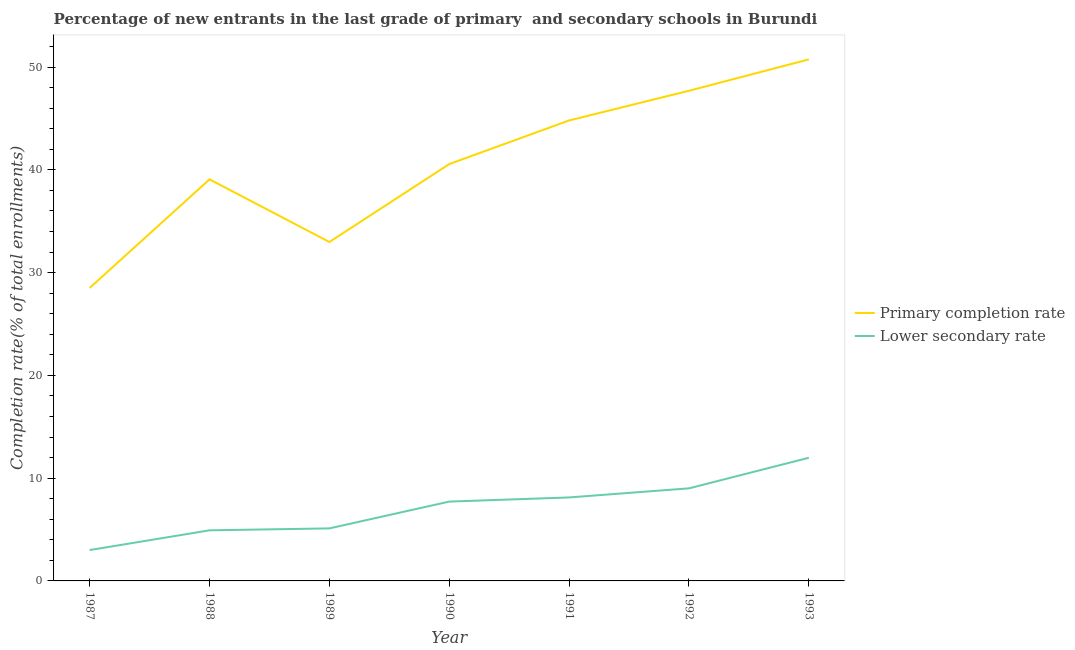What is the completion rate in primary schools in 1991?
Keep it short and to the point. 44.81. Across all years, what is the maximum completion rate in primary schools?
Your answer should be very brief. 50.75. Across all years, what is the minimum completion rate in primary schools?
Your answer should be compact. 28.51. In which year was the completion rate in secondary schools minimum?
Make the answer very short. 1987. What is the total completion rate in primary schools in the graph?
Provide a short and direct response. 284.41. What is the difference between the completion rate in secondary schools in 1987 and that in 1988?
Offer a very short reply. -1.92. What is the difference between the completion rate in secondary schools in 1993 and the completion rate in primary schools in 1992?
Make the answer very short. -35.72. What is the average completion rate in primary schools per year?
Your answer should be very brief. 40.63. In the year 1991, what is the difference between the completion rate in secondary schools and completion rate in primary schools?
Offer a terse response. -36.69. In how many years, is the completion rate in primary schools greater than 10 %?
Your answer should be very brief. 7. What is the ratio of the completion rate in secondary schools in 1988 to that in 1991?
Your response must be concise. 0.61. What is the difference between the highest and the second highest completion rate in primary schools?
Offer a very short reply. 3.05. What is the difference between the highest and the lowest completion rate in primary schools?
Offer a terse response. 22.24. Is the sum of the completion rate in secondary schools in 1991 and 1992 greater than the maximum completion rate in primary schools across all years?
Keep it short and to the point. No. Is the completion rate in secondary schools strictly greater than the completion rate in primary schools over the years?
Offer a terse response. No. Is the completion rate in secondary schools strictly less than the completion rate in primary schools over the years?
Keep it short and to the point. Yes. How many years are there in the graph?
Your answer should be very brief. 7. Where does the legend appear in the graph?
Provide a short and direct response. Center right. How are the legend labels stacked?
Provide a short and direct response. Vertical. What is the title of the graph?
Keep it short and to the point. Percentage of new entrants in the last grade of primary  and secondary schools in Burundi. What is the label or title of the Y-axis?
Provide a succinct answer. Completion rate(% of total enrollments). What is the Completion rate(% of total enrollments) in Primary completion rate in 1987?
Give a very brief answer. 28.51. What is the Completion rate(% of total enrollments) in Lower secondary rate in 1987?
Ensure brevity in your answer.  3. What is the Completion rate(% of total enrollments) of Primary completion rate in 1988?
Make the answer very short. 39.08. What is the Completion rate(% of total enrollments) of Lower secondary rate in 1988?
Offer a very short reply. 4.92. What is the Completion rate(% of total enrollments) of Primary completion rate in 1989?
Your response must be concise. 32.98. What is the Completion rate(% of total enrollments) in Lower secondary rate in 1989?
Keep it short and to the point. 5.11. What is the Completion rate(% of total enrollments) in Primary completion rate in 1990?
Your answer should be compact. 40.57. What is the Completion rate(% of total enrollments) in Lower secondary rate in 1990?
Offer a terse response. 7.72. What is the Completion rate(% of total enrollments) of Primary completion rate in 1991?
Your response must be concise. 44.81. What is the Completion rate(% of total enrollments) of Lower secondary rate in 1991?
Make the answer very short. 8.12. What is the Completion rate(% of total enrollments) of Primary completion rate in 1992?
Offer a very short reply. 47.7. What is the Completion rate(% of total enrollments) of Lower secondary rate in 1992?
Your answer should be compact. 9.01. What is the Completion rate(% of total enrollments) in Primary completion rate in 1993?
Offer a terse response. 50.75. What is the Completion rate(% of total enrollments) in Lower secondary rate in 1993?
Your answer should be very brief. 11.98. Across all years, what is the maximum Completion rate(% of total enrollments) in Primary completion rate?
Offer a terse response. 50.75. Across all years, what is the maximum Completion rate(% of total enrollments) of Lower secondary rate?
Offer a terse response. 11.98. Across all years, what is the minimum Completion rate(% of total enrollments) in Primary completion rate?
Your answer should be compact. 28.51. Across all years, what is the minimum Completion rate(% of total enrollments) of Lower secondary rate?
Provide a short and direct response. 3. What is the total Completion rate(% of total enrollments) of Primary completion rate in the graph?
Make the answer very short. 284.41. What is the total Completion rate(% of total enrollments) in Lower secondary rate in the graph?
Your answer should be compact. 49.88. What is the difference between the Completion rate(% of total enrollments) in Primary completion rate in 1987 and that in 1988?
Keep it short and to the point. -10.57. What is the difference between the Completion rate(% of total enrollments) of Lower secondary rate in 1987 and that in 1988?
Provide a short and direct response. -1.92. What is the difference between the Completion rate(% of total enrollments) in Primary completion rate in 1987 and that in 1989?
Your answer should be very brief. -4.47. What is the difference between the Completion rate(% of total enrollments) of Lower secondary rate in 1987 and that in 1989?
Offer a very short reply. -2.11. What is the difference between the Completion rate(% of total enrollments) in Primary completion rate in 1987 and that in 1990?
Offer a terse response. -12.05. What is the difference between the Completion rate(% of total enrollments) of Lower secondary rate in 1987 and that in 1990?
Make the answer very short. -4.72. What is the difference between the Completion rate(% of total enrollments) of Primary completion rate in 1987 and that in 1991?
Provide a succinct answer. -16.3. What is the difference between the Completion rate(% of total enrollments) in Lower secondary rate in 1987 and that in 1991?
Give a very brief answer. -5.12. What is the difference between the Completion rate(% of total enrollments) of Primary completion rate in 1987 and that in 1992?
Your answer should be very brief. -19.19. What is the difference between the Completion rate(% of total enrollments) of Lower secondary rate in 1987 and that in 1992?
Offer a very short reply. -6.01. What is the difference between the Completion rate(% of total enrollments) in Primary completion rate in 1987 and that in 1993?
Provide a succinct answer. -22.24. What is the difference between the Completion rate(% of total enrollments) of Lower secondary rate in 1987 and that in 1993?
Your answer should be very brief. -8.98. What is the difference between the Completion rate(% of total enrollments) of Primary completion rate in 1988 and that in 1989?
Offer a terse response. 6.09. What is the difference between the Completion rate(% of total enrollments) in Lower secondary rate in 1988 and that in 1989?
Give a very brief answer. -0.19. What is the difference between the Completion rate(% of total enrollments) in Primary completion rate in 1988 and that in 1990?
Provide a short and direct response. -1.49. What is the difference between the Completion rate(% of total enrollments) of Lower secondary rate in 1988 and that in 1990?
Your answer should be very brief. -2.8. What is the difference between the Completion rate(% of total enrollments) in Primary completion rate in 1988 and that in 1991?
Your answer should be very brief. -5.73. What is the difference between the Completion rate(% of total enrollments) of Lower secondary rate in 1988 and that in 1991?
Offer a very short reply. -3.2. What is the difference between the Completion rate(% of total enrollments) of Primary completion rate in 1988 and that in 1992?
Your answer should be very brief. -8.62. What is the difference between the Completion rate(% of total enrollments) of Lower secondary rate in 1988 and that in 1992?
Your answer should be compact. -4.09. What is the difference between the Completion rate(% of total enrollments) in Primary completion rate in 1988 and that in 1993?
Provide a short and direct response. -11.67. What is the difference between the Completion rate(% of total enrollments) in Lower secondary rate in 1988 and that in 1993?
Provide a succinct answer. -7.06. What is the difference between the Completion rate(% of total enrollments) of Primary completion rate in 1989 and that in 1990?
Your response must be concise. -7.58. What is the difference between the Completion rate(% of total enrollments) in Lower secondary rate in 1989 and that in 1990?
Make the answer very short. -2.61. What is the difference between the Completion rate(% of total enrollments) in Primary completion rate in 1989 and that in 1991?
Provide a short and direct response. -11.83. What is the difference between the Completion rate(% of total enrollments) in Lower secondary rate in 1989 and that in 1991?
Ensure brevity in your answer.  -3.01. What is the difference between the Completion rate(% of total enrollments) in Primary completion rate in 1989 and that in 1992?
Your answer should be compact. -14.72. What is the difference between the Completion rate(% of total enrollments) of Lower secondary rate in 1989 and that in 1992?
Offer a terse response. -3.9. What is the difference between the Completion rate(% of total enrollments) in Primary completion rate in 1989 and that in 1993?
Offer a terse response. -17.77. What is the difference between the Completion rate(% of total enrollments) of Lower secondary rate in 1989 and that in 1993?
Ensure brevity in your answer.  -6.87. What is the difference between the Completion rate(% of total enrollments) of Primary completion rate in 1990 and that in 1991?
Offer a very short reply. -4.24. What is the difference between the Completion rate(% of total enrollments) in Lower secondary rate in 1990 and that in 1991?
Offer a very short reply. -0.4. What is the difference between the Completion rate(% of total enrollments) in Primary completion rate in 1990 and that in 1992?
Provide a succinct answer. -7.13. What is the difference between the Completion rate(% of total enrollments) in Lower secondary rate in 1990 and that in 1992?
Keep it short and to the point. -1.29. What is the difference between the Completion rate(% of total enrollments) in Primary completion rate in 1990 and that in 1993?
Give a very brief answer. -10.19. What is the difference between the Completion rate(% of total enrollments) of Lower secondary rate in 1990 and that in 1993?
Give a very brief answer. -4.26. What is the difference between the Completion rate(% of total enrollments) in Primary completion rate in 1991 and that in 1992?
Provide a short and direct response. -2.89. What is the difference between the Completion rate(% of total enrollments) in Lower secondary rate in 1991 and that in 1992?
Offer a very short reply. -0.89. What is the difference between the Completion rate(% of total enrollments) in Primary completion rate in 1991 and that in 1993?
Your answer should be very brief. -5.94. What is the difference between the Completion rate(% of total enrollments) in Lower secondary rate in 1991 and that in 1993?
Provide a succinct answer. -3.86. What is the difference between the Completion rate(% of total enrollments) of Primary completion rate in 1992 and that in 1993?
Ensure brevity in your answer.  -3.05. What is the difference between the Completion rate(% of total enrollments) in Lower secondary rate in 1992 and that in 1993?
Offer a very short reply. -2.97. What is the difference between the Completion rate(% of total enrollments) of Primary completion rate in 1987 and the Completion rate(% of total enrollments) of Lower secondary rate in 1988?
Provide a short and direct response. 23.59. What is the difference between the Completion rate(% of total enrollments) in Primary completion rate in 1987 and the Completion rate(% of total enrollments) in Lower secondary rate in 1989?
Give a very brief answer. 23.4. What is the difference between the Completion rate(% of total enrollments) of Primary completion rate in 1987 and the Completion rate(% of total enrollments) of Lower secondary rate in 1990?
Your response must be concise. 20.79. What is the difference between the Completion rate(% of total enrollments) of Primary completion rate in 1987 and the Completion rate(% of total enrollments) of Lower secondary rate in 1991?
Make the answer very short. 20.39. What is the difference between the Completion rate(% of total enrollments) of Primary completion rate in 1987 and the Completion rate(% of total enrollments) of Lower secondary rate in 1992?
Keep it short and to the point. 19.5. What is the difference between the Completion rate(% of total enrollments) in Primary completion rate in 1987 and the Completion rate(% of total enrollments) in Lower secondary rate in 1993?
Provide a short and direct response. 16.53. What is the difference between the Completion rate(% of total enrollments) in Primary completion rate in 1988 and the Completion rate(% of total enrollments) in Lower secondary rate in 1989?
Provide a succinct answer. 33.97. What is the difference between the Completion rate(% of total enrollments) of Primary completion rate in 1988 and the Completion rate(% of total enrollments) of Lower secondary rate in 1990?
Your response must be concise. 31.36. What is the difference between the Completion rate(% of total enrollments) of Primary completion rate in 1988 and the Completion rate(% of total enrollments) of Lower secondary rate in 1991?
Make the answer very short. 30.95. What is the difference between the Completion rate(% of total enrollments) of Primary completion rate in 1988 and the Completion rate(% of total enrollments) of Lower secondary rate in 1992?
Provide a succinct answer. 30.07. What is the difference between the Completion rate(% of total enrollments) of Primary completion rate in 1988 and the Completion rate(% of total enrollments) of Lower secondary rate in 1993?
Offer a terse response. 27.09. What is the difference between the Completion rate(% of total enrollments) in Primary completion rate in 1989 and the Completion rate(% of total enrollments) in Lower secondary rate in 1990?
Offer a very short reply. 25.26. What is the difference between the Completion rate(% of total enrollments) of Primary completion rate in 1989 and the Completion rate(% of total enrollments) of Lower secondary rate in 1991?
Provide a succinct answer. 24.86. What is the difference between the Completion rate(% of total enrollments) in Primary completion rate in 1989 and the Completion rate(% of total enrollments) in Lower secondary rate in 1992?
Make the answer very short. 23.97. What is the difference between the Completion rate(% of total enrollments) in Primary completion rate in 1989 and the Completion rate(% of total enrollments) in Lower secondary rate in 1993?
Give a very brief answer. 21. What is the difference between the Completion rate(% of total enrollments) of Primary completion rate in 1990 and the Completion rate(% of total enrollments) of Lower secondary rate in 1991?
Keep it short and to the point. 32.44. What is the difference between the Completion rate(% of total enrollments) in Primary completion rate in 1990 and the Completion rate(% of total enrollments) in Lower secondary rate in 1992?
Your answer should be compact. 31.56. What is the difference between the Completion rate(% of total enrollments) in Primary completion rate in 1990 and the Completion rate(% of total enrollments) in Lower secondary rate in 1993?
Your answer should be compact. 28.58. What is the difference between the Completion rate(% of total enrollments) of Primary completion rate in 1991 and the Completion rate(% of total enrollments) of Lower secondary rate in 1992?
Your answer should be compact. 35.8. What is the difference between the Completion rate(% of total enrollments) in Primary completion rate in 1991 and the Completion rate(% of total enrollments) in Lower secondary rate in 1993?
Give a very brief answer. 32.83. What is the difference between the Completion rate(% of total enrollments) in Primary completion rate in 1992 and the Completion rate(% of total enrollments) in Lower secondary rate in 1993?
Give a very brief answer. 35.72. What is the average Completion rate(% of total enrollments) in Primary completion rate per year?
Provide a succinct answer. 40.63. What is the average Completion rate(% of total enrollments) in Lower secondary rate per year?
Your answer should be compact. 7.13. In the year 1987, what is the difference between the Completion rate(% of total enrollments) in Primary completion rate and Completion rate(% of total enrollments) in Lower secondary rate?
Provide a short and direct response. 25.51. In the year 1988, what is the difference between the Completion rate(% of total enrollments) of Primary completion rate and Completion rate(% of total enrollments) of Lower secondary rate?
Provide a succinct answer. 34.16. In the year 1989, what is the difference between the Completion rate(% of total enrollments) of Primary completion rate and Completion rate(% of total enrollments) of Lower secondary rate?
Make the answer very short. 27.87. In the year 1990, what is the difference between the Completion rate(% of total enrollments) of Primary completion rate and Completion rate(% of total enrollments) of Lower secondary rate?
Your answer should be very brief. 32.85. In the year 1991, what is the difference between the Completion rate(% of total enrollments) in Primary completion rate and Completion rate(% of total enrollments) in Lower secondary rate?
Provide a succinct answer. 36.69. In the year 1992, what is the difference between the Completion rate(% of total enrollments) of Primary completion rate and Completion rate(% of total enrollments) of Lower secondary rate?
Offer a very short reply. 38.69. In the year 1993, what is the difference between the Completion rate(% of total enrollments) in Primary completion rate and Completion rate(% of total enrollments) in Lower secondary rate?
Offer a terse response. 38.77. What is the ratio of the Completion rate(% of total enrollments) in Primary completion rate in 1987 to that in 1988?
Make the answer very short. 0.73. What is the ratio of the Completion rate(% of total enrollments) of Lower secondary rate in 1987 to that in 1988?
Your answer should be very brief. 0.61. What is the ratio of the Completion rate(% of total enrollments) of Primary completion rate in 1987 to that in 1989?
Offer a very short reply. 0.86. What is the ratio of the Completion rate(% of total enrollments) of Lower secondary rate in 1987 to that in 1989?
Offer a very short reply. 0.59. What is the ratio of the Completion rate(% of total enrollments) of Primary completion rate in 1987 to that in 1990?
Provide a short and direct response. 0.7. What is the ratio of the Completion rate(% of total enrollments) of Lower secondary rate in 1987 to that in 1990?
Your response must be concise. 0.39. What is the ratio of the Completion rate(% of total enrollments) in Primary completion rate in 1987 to that in 1991?
Make the answer very short. 0.64. What is the ratio of the Completion rate(% of total enrollments) of Lower secondary rate in 1987 to that in 1991?
Make the answer very short. 0.37. What is the ratio of the Completion rate(% of total enrollments) of Primary completion rate in 1987 to that in 1992?
Keep it short and to the point. 0.6. What is the ratio of the Completion rate(% of total enrollments) of Lower secondary rate in 1987 to that in 1992?
Make the answer very short. 0.33. What is the ratio of the Completion rate(% of total enrollments) of Primary completion rate in 1987 to that in 1993?
Give a very brief answer. 0.56. What is the ratio of the Completion rate(% of total enrollments) of Lower secondary rate in 1987 to that in 1993?
Provide a succinct answer. 0.25. What is the ratio of the Completion rate(% of total enrollments) in Primary completion rate in 1988 to that in 1989?
Give a very brief answer. 1.18. What is the ratio of the Completion rate(% of total enrollments) in Lower secondary rate in 1988 to that in 1989?
Ensure brevity in your answer.  0.96. What is the ratio of the Completion rate(% of total enrollments) in Primary completion rate in 1988 to that in 1990?
Offer a terse response. 0.96. What is the ratio of the Completion rate(% of total enrollments) in Lower secondary rate in 1988 to that in 1990?
Your answer should be compact. 0.64. What is the ratio of the Completion rate(% of total enrollments) in Primary completion rate in 1988 to that in 1991?
Your answer should be very brief. 0.87. What is the ratio of the Completion rate(% of total enrollments) of Lower secondary rate in 1988 to that in 1991?
Ensure brevity in your answer.  0.61. What is the ratio of the Completion rate(% of total enrollments) in Primary completion rate in 1988 to that in 1992?
Your response must be concise. 0.82. What is the ratio of the Completion rate(% of total enrollments) in Lower secondary rate in 1988 to that in 1992?
Your answer should be compact. 0.55. What is the ratio of the Completion rate(% of total enrollments) in Primary completion rate in 1988 to that in 1993?
Provide a short and direct response. 0.77. What is the ratio of the Completion rate(% of total enrollments) of Lower secondary rate in 1988 to that in 1993?
Give a very brief answer. 0.41. What is the ratio of the Completion rate(% of total enrollments) in Primary completion rate in 1989 to that in 1990?
Offer a very short reply. 0.81. What is the ratio of the Completion rate(% of total enrollments) of Lower secondary rate in 1989 to that in 1990?
Keep it short and to the point. 0.66. What is the ratio of the Completion rate(% of total enrollments) in Primary completion rate in 1989 to that in 1991?
Ensure brevity in your answer.  0.74. What is the ratio of the Completion rate(% of total enrollments) of Lower secondary rate in 1989 to that in 1991?
Ensure brevity in your answer.  0.63. What is the ratio of the Completion rate(% of total enrollments) in Primary completion rate in 1989 to that in 1992?
Provide a short and direct response. 0.69. What is the ratio of the Completion rate(% of total enrollments) in Lower secondary rate in 1989 to that in 1992?
Your answer should be compact. 0.57. What is the ratio of the Completion rate(% of total enrollments) of Primary completion rate in 1989 to that in 1993?
Your answer should be compact. 0.65. What is the ratio of the Completion rate(% of total enrollments) of Lower secondary rate in 1989 to that in 1993?
Offer a terse response. 0.43. What is the ratio of the Completion rate(% of total enrollments) of Primary completion rate in 1990 to that in 1991?
Keep it short and to the point. 0.91. What is the ratio of the Completion rate(% of total enrollments) of Lower secondary rate in 1990 to that in 1991?
Your response must be concise. 0.95. What is the ratio of the Completion rate(% of total enrollments) of Primary completion rate in 1990 to that in 1992?
Give a very brief answer. 0.85. What is the ratio of the Completion rate(% of total enrollments) of Lower secondary rate in 1990 to that in 1992?
Your answer should be compact. 0.86. What is the ratio of the Completion rate(% of total enrollments) of Primary completion rate in 1990 to that in 1993?
Provide a short and direct response. 0.8. What is the ratio of the Completion rate(% of total enrollments) of Lower secondary rate in 1990 to that in 1993?
Keep it short and to the point. 0.64. What is the ratio of the Completion rate(% of total enrollments) of Primary completion rate in 1991 to that in 1992?
Ensure brevity in your answer.  0.94. What is the ratio of the Completion rate(% of total enrollments) of Lower secondary rate in 1991 to that in 1992?
Your response must be concise. 0.9. What is the ratio of the Completion rate(% of total enrollments) of Primary completion rate in 1991 to that in 1993?
Give a very brief answer. 0.88. What is the ratio of the Completion rate(% of total enrollments) in Lower secondary rate in 1991 to that in 1993?
Ensure brevity in your answer.  0.68. What is the ratio of the Completion rate(% of total enrollments) in Primary completion rate in 1992 to that in 1993?
Keep it short and to the point. 0.94. What is the ratio of the Completion rate(% of total enrollments) in Lower secondary rate in 1992 to that in 1993?
Provide a short and direct response. 0.75. What is the difference between the highest and the second highest Completion rate(% of total enrollments) in Primary completion rate?
Your response must be concise. 3.05. What is the difference between the highest and the second highest Completion rate(% of total enrollments) of Lower secondary rate?
Give a very brief answer. 2.97. What is the difference between the highest and the lowest Completion rate(% of total enrollments) of Primary completion rate?
Provide a succinct answer. 22.24. What is the difference between the highest and the lowest Completion rate(% of total enrollments) in Lower secondary rate?
Offer a terse response. 8.98. 